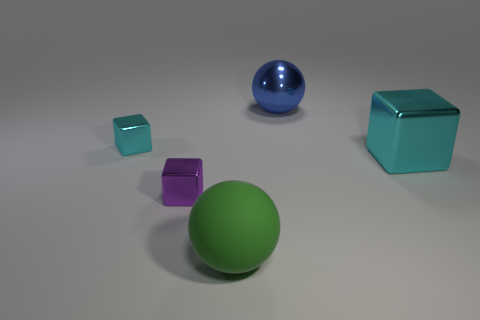The object that is the same color as the large metallic block is what size?
Keep it short and to the point. Small. What number of objects are either metallic balls or big cyan metallic objects that are on the right side of the rubber thing?
Your response must be concise. 2. There is a purple cube that is the same material as the blue thing; what size is it?
Provide a short and direct response. Small. What number of purple objects are either tiny objects or blocks?
Make the answer very short. 1. What is the shape of the small metal thing that is the same color as the big block?
Ensure brevity in your answer.  Cube. Is there anything else that is made of the same material as the big green thing?
Offer a very short reply. No. There is a cyan shiny thing that is on the left side of the tiny purple metallic block; is its shape the same as the cyan metallic thing to the right of the large blue metallic ball?
Give a very brief answer. Yes. How many big metal balls are there?
Your response must be concise. 1. The large blue thing that is made of the same material as the small purple object is what shape?
Ensure brevity in your answer.  Sphere. Are there any other things that are the same color as the matte sphere?
Your response must be concise. No. 